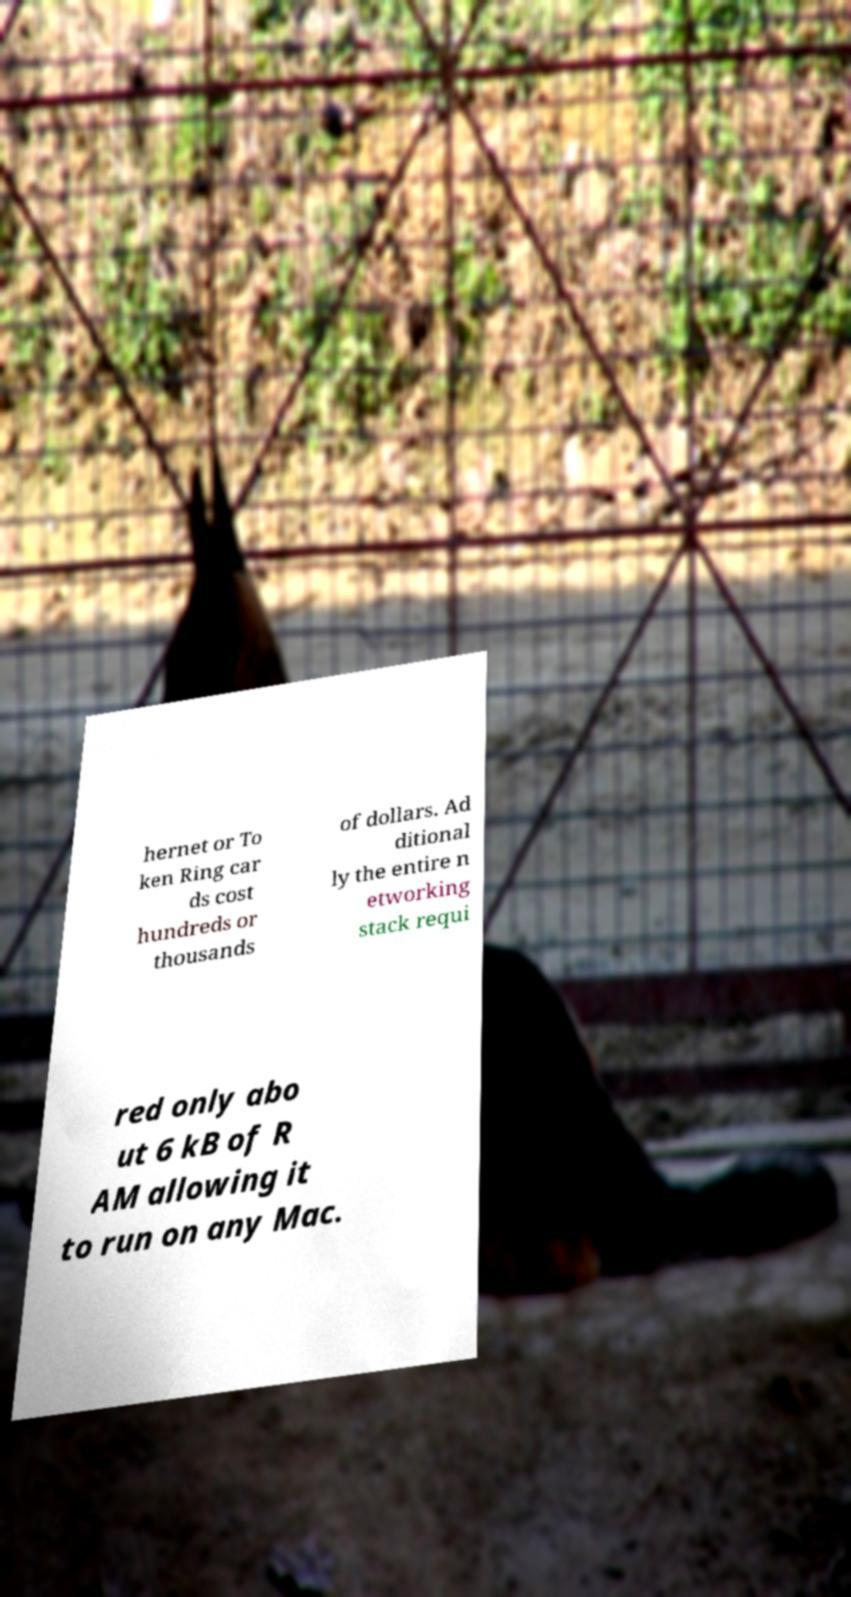Could you assist in decoding the text presented in this image and type it out clearly? hernet or To ken Ring car ds cost hundreds or thousands of dollars. Ad ditional ly the entire n etworking stack requi red only abo ut 6 kB of R AM allowing it to run on any Mac. 